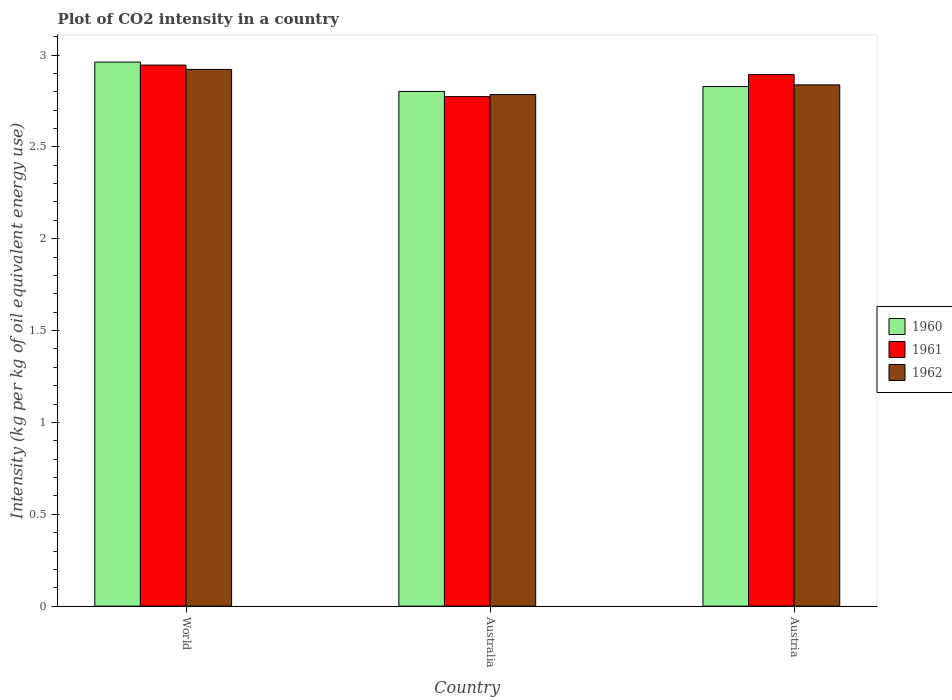How many groups of bars are there?
Your answer should be compact. 3. Are the number of bars on each tick of the X-axis equal?
Provide a short and direct response. Yes. How many bars are there on the 3rd tick from the left?
Ensure brevity in your answer.  3. What is the label of the 3rd group of bars from the left?
Your answer should be compact. Austria. What is the CO2 intensity in in 1962 in World?
Provide a succinct answer. 2.92. Across all countries, what is the maximum CO2 intensity in in 1960?
Keep it short and to the point. 2.96. Across all countries, what is the minimum CO2 intensity in in 1960?
Your response must be concise. 2.8. In which country was the CO2 intensity in in 1962 minimum?
Ensure brevity in your answer.  Australia. What is the total CO2 intensity in in 1962 in the graph?
Provide a succinct answer. 8.54. What is the difference between the CO2 intensity in in 1960 in Australia and that in World?
Ensure brevity in your answer.  -0.16. What is the difference between the CO2 intensity in in 1960 in World and the CO2 intensity in in 1962 in Austria?
Offer a very short reply. 0.12. What is the average CO2 intensity in in 1960 per country?
Provide a short and direct response. 2.86. What is the difference between the CO2 intensity in of/in 1962 and CO2 intensity in of/in 1961 in Australia?
Your answer should be compact. 0.01. In how many countries, is the CO2 intensity in in 1960 greater than 1.7 kg?
Your response must be concise. 3. What is the ratio of the CO2 intensity in in 1960 in Austria to that in World?
Provide a succinct answer. 0.96. Is the CO2 intensity in in 1960 in Austria less than that in World?
Give a very brief answer. Yes. Is the difference between the CO2 intensity in in 1962 in Austria and World greater than the difference between the CO2 intensity in in 1961 in Austria and World?
Your answer should be compact. No. What is the difference between the highest and the second highest CO2 intensity in in 1961?
Provide a succinct answer. 0.05. What is the difference between the highest and the lowest CO2 intensity in in 1962?
Your answer should be compact. 0.14. What does the 1st bar from the left in Australia represents?
Provide a short and direct response. 1960. Are all the bars in the graph horizontal?
Offer a terse response. No. How many countries are there in the graph?
Offer a very short reply. 3. Are the values on the major ticks of Y-axis written in scientific E-notation?
Provide a succinct answer. No. Does the graph contain any zero values?
Your answer should be very brief. No. How many legend labels are there?
Your answer should be compact. 3. How are the legend labels stacked?
Your answer should be compact. Vertical. What is the title of the graph?
Provide a succinct answer. Plot of CO2 intensity in a country. What is the label or title of the Y-axis?
Your answer should be compact. Intensity (kg per kg of oil equivalent energy use). What is the Intensity (kg per kg of oil equivalent energy use) of 1960 in World?
Keep it short and to the point. 2.96. What is the Intensity (kg per kg of oil equivalent energy use) in 1961 in World?
Provide a short and direct response. 2.95. What is the Intensity (kg per kg of oil equivalent energy use) of 1962 in World?
Provide a short and direct response. 2.92. What is the Intensity (kg per kg of oil equivalent energy use) in 1960 in Australia?
Provide a short and direct response. 2.8. What is the Intensity (kg per kg of oil equivalent energy use) in 1961 in Australia?
Provide a short and direct response. 2.77. What is the Intensity (kg per kg of oil equivalent energy use) of 1962 in Australia?
Your response must be concise. 2.78. What is the Intensity (kg per kg of oil equivalent energy use) in 1960 in Austria?
Your response must be concise. 2.83. What is the Intensity (kg per kg of oil equivalent energy use) of 1961 in Austria?
Provide a short and direct response. 2.89. What is the Intensity (kg per kg of oil equivalent energy use) of 1962 in Austria?
Your answer should be very brief. 2.84. Across all countries, what is the maximum Intensity (kg per kg of oil equivalent energy use) in 1960?
Provide a short and direct response. 2.96. Across all countries, what is the maximum Intensity (kg per kg of oil equivalent energy use) of 1961?
Offer a very short reply. 2.95. Across all countries, what is the maximum Intensity (kg per kg of oil equivalent energy use) in 1962?
Offer a terse response. 2.92. Across all countries, what is the minimum Intensity (kg per kg of oil equivalent energy use) in 1960?
Offer a very short reply. 2.8. Across all countries, what is the minimum Intensity (kg per kg of oil equivalent energy use) of 1961?
Ensure brevity in your answer.  2.77. Across all countries, what is the minimum Intensity (kg per kg of oil equivalent energy use) of 1962?
Give a very brief answer. 2.78. What is the total Intensity (kg per kg of oil equivalent energy use) of 1960 in the graph?
Provide a succinct answer. 8.59. What is the total Intensity (kg per kg of oil equivalent energy use) of 1961 in the graph?
Provide a succinct answer. 8.61. What is the total Intensity (kg per kg of oil equivalent energy use) of 1962 in the graph?
Ensure brevity in your answer.  8.54. What is the difference between the Intensity (kg per kg of oil equivalent energy use) of 1960 in World and that in Australia?
Provide a short and direct response. 0.16. What is the difference between the Intensity (kg per kg of oil equivalent energy use) of 1961 in World and that in Australia?
Keep it short and to the point. 0.17. What is the difference between the Intensity (kg per kg of oil equivalent energy use) in 1962 in World and that in Australia?
Ensure brevity in your answer.  0.14. What is the difference between the Intensity (kg per kg of oil equivalent energy use) in 1960 in World and that in Austria?
Give a very brief answer. 0.13. What is the difference between the Intensity (kg per kg of oil equivalent energy use) of 1961 in World and that in Austria?
Offer a very short reply. 0.05. What is the difference between the Intensity (kg per kg of oil equivalent energy use) of 1962 in World and that in Austria?
Your response must be concise. 0.08. What is the difference between the Intensity (kg per kg of oil equivalent energy use) in 1960 in Australia and that in Austria?
Your response must be concise. -0.03. What is the difference between the Intensity (kg per kg of oil equivalent energy use) of 1961 in Australia and that in Austria?
Ensure brevity in your answer.  -0.12. What is the difference between the Intensity (kg per kg of oil equivalent energy use) of 1962 in Australia and that in Austria?
Offer a terse response. -0.05. What is the difference between the Intensity (kg per kg of oil equivalent energy use) in 1960 in World and the Intensity (kg per kg of oil equivalent energy use) in 1961 in Australia?
Offer a very short reply. 0.19. What is the difference between the Intensity (kg per kg of oil equivalent energy use) in 1960 in World and the Intensity (kg per kg of oil equivalent energy use) in 1962 in Australia?
Make the answer very short. 0.18. What is the difference between the Intensity (kg per kg of oil equivalent energy use) of 1961 in World and the Intensity (kg per kg of oil equivalent energy use) of 1962 in Australia?
Make the answer very short. 0.16. What is the difference between the Intensity (kg per kg of oil equivalent energy use) of 1960 in World and the Intensity (kg per kg of oil equivalent energy use) of 1961 in Austria?
Make the answer very short. 0.07. What is the difference between the Intensity (kg per kg of oil equivalent energy use) of 1960 in World and the Intensity (kg per kg of oil equivalent energy use) of 1962 in Austria?
Offer a terse response. 0.12. What is the difference between the Intensity (kg per kg of oil equivalent energy use) of 1961 in World and the Intensity (kg per kg of oil equivalent energy use) of 1962 in Austria?
Offer a very short reply. 0.11. What is the difference between the Intensity (kg per kg of oil equivalent energy use) of 1960 in Australia and the Intensity (kg per kg of oil equivalent energy use) of 1961 in Austria?
Your answer should be very brief. -0.09. What is the difference between the Intensity (kg per kg of oil equivalent energy use) of 1960 in Australia and the Intensity (kg per kg of oil equivalent energy use) of 1962 in Austria?
Provide a short and direct response. -0.04. What is the difference between the Intensity (kg per kg of oil equivalent energy use) of 1961 in Australia and the Intensity (kg per kg of oil equivalent energy use) of 1962 in Austria?
Your response must be concise. -0.06. What is the average Intensity (kg per kg of oil equivalent energy use) in 1960 per country?
Provide a short and direct response. 2.86. What is the average Intensity (kg per kg of oil equivalent energy use) in 1961 per country?
Offer a terse response. 2.87. What is the average Intensity (kg per kg of oil equivalent energy use) of 1962 per country?
Provide a short and direct response. 2.85. What is the difference between the Intensity (kg per kg of oil equivalent energy use) in 1960 and Intensity (kg per kg of oil equivalent energy use) in 1961 in World?
Make the answer very short. 0.02. What is the difference between the Intensity (kg per kg of oil equivalent energy use) of 1960 and Intensity (kg per kg of oil equivalent energy use) of 1962 in World?
Provide a short and direct response. 0.04. What is the difference between the Intensity (kg per kg of oil equivalent energy use) of 1961 and Intensity (kg per kg of oil equivalent energy use) of 1962 in World?
Your answer should be compact. 0.02. What is the difference between the Intensity (kg per kg of oil equivalent energy use) in 1960 and Intensity (kg per kg of oil equivalent energy use) in 1961 in Australia?
Your answer should be compact. 0.03. What is the difference between the Intensity (kg per kg of oil equivalent energy use) of 1960 and Intensity (kg per kg of oil equivalent energy use) of 1962 in Australia?
Provide a short and direct response. 0.02. What is the difference between the Intensity (kg per kg of oil equivalent energy use) of 1961 and Intensity (kg per kg of oil equivalent energy use) of 1962 in Australia?
Offer a very short reply. -0.01. What is the difference between the Intensity (kg per kg of oil equivalent energy use) of 1960 and Intensity (kg per kg of oil equivalent energy use) of 1961 in Austria?
Your response must be concise. -0.07. What is the difference between the Intensity (kg per kg of oil equivalent energy use) of 1960 and Intensity (kg per kg of oil equivalent energy use) of 1962 in Austria?
Keep it short and to the point. -0.01. What is the difference between the Intensity (kg per kg of oil equivalent energy use) in 1961 and Intensity (kg per kg of oil equivalent energy use) in 1962 in Austria?
Provide a short and direct response. 0.06. What is the ratio of the Intensity (kg per kg of oil equivalent energy use) of 1960 in World to that in Australia?
Give a very brief answer. 1.06. What is the ratio of the Intensity (kg per kg of oil equivalent energy use) in 1961 in World to that in Australia?
Provide a short and direct response. 1.06. What is the ratio of the Intensity (kg per kg of oil equivalent energy use) in 1962 in World to that in Australia?
Your answer should be very brief. 1.05. What is the ratio of the Intensity (kg per kg of oil equivalent energy use) in 1960 in World to that in Austria?
Keep it short and to the point. 1.05. What is the ratio of the Intensity (kg per kg of oil equivalent energy use) of 1961 in World to that in Austria?
Your response must be concise. 1.02. What is the ratio of the Intensity (kg per kg of oil equivalent energy use) in 1962 in World to that in Austria?
Provide a short and direct response. 1.03. What is the ratio of the Intensity (kg per kg of oil equivalent energy use) of 1960 in Australia to that in Austria?
Your answer should be very brief. 0.99. What is the ratio of the Intensity (kg per kg of oil equivalent energy use) in 1961 in Australia to that in Austria?
Provide a succinct answer. 0.96. What is the ratio of the Intensity (kg per kg of oil equivalent energy use) of 1962 in Australia to that in Austria?
Offer a very short reply. 0.98. What is the difference between the highest and the second highest Intensity (kg per kg of oil equivalent energy use) in 1960?
Give a very brief answer. 0.13. What is the difference between the highest and the second highest Intensity (kg per kg of oil equivalent energy use) in 1961?
Provide a short and direct response. 0.05. What is the difference between the highest and the second highest Intensity (kg per kg of oil equivalent energy use) of 1962?
Offer a very short reply. 0.08. What is the difference between the highest and the lowest Intensity (kg per kg of oil equivalent energy use) in 1960?
Your answer should be compact. 0.16. What is the difference between the highest and the lowest Intensity (kg per kg of oil equivalent energy use) of 1961?
Your answer should be compact. 0.17. What is the difference between the highest and the lowest Intensity (kg per kg of oil equivalent energy use) of 1962?
Offer a terse response. 0.14. 